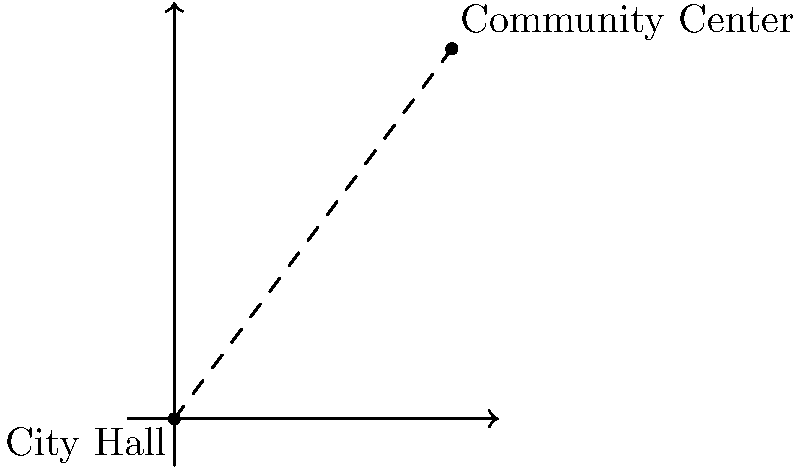As a local reporter, you're covering a story about the city's plans to improve connectivity between two important landmarks. The City Hall is located at the origin (0,0) on a coordinate plane, while the Community Center is at (6,8). What is the straight-line distance between these two landmarks? Round your answer to the nearest tenth of a mile. To find the distance between two points on a coordinate plane, we can use the distance formula:

$$d = \sqrt{(x_2-x_1)^2 + (y_2-y_1)^2}$$

Where $(x_1,y_1)$ is the coordinate of the first point (City Hall) and $(x_2,y_2)$ is the coordinate of the second point (Community Center).

Step 1: Identify the coordinates
- City Hall: $(x_1,y_1) = (0,0)$
- Community Center: $(x_2,y_2) = (6,8)$

Step 2: Plug the values into the distance formula
$$d = \sqrt{(6-0)^2 + (8-0)^2}$$

Step 3: Simplify
$$d = \sqrt{6^2 + 8^2}$$
$$d = \sqrt{36 + 64}$$
$$d = \sqrt{100}$$

Step 4: Calculate the square root
$$d = 10$$

Therefore, the straight-line distance between City Hall and the Community Center is 10 miles.

Since the question asks to round to the nearest tenth of a mile, the final answer is 10.0 miles.
Answer: 10.0 miles 